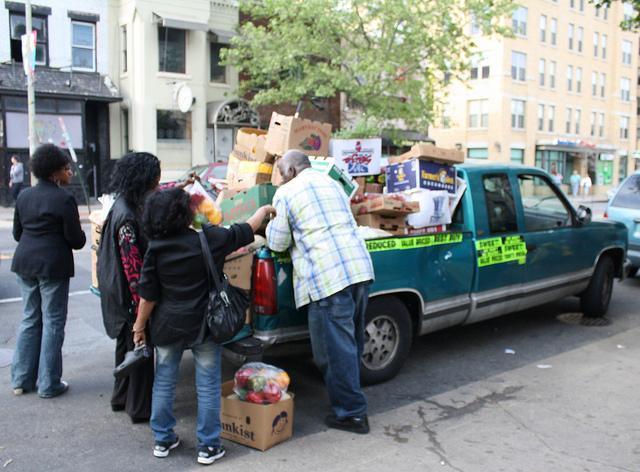How many people are there?
Give a very brief answer. 4. 